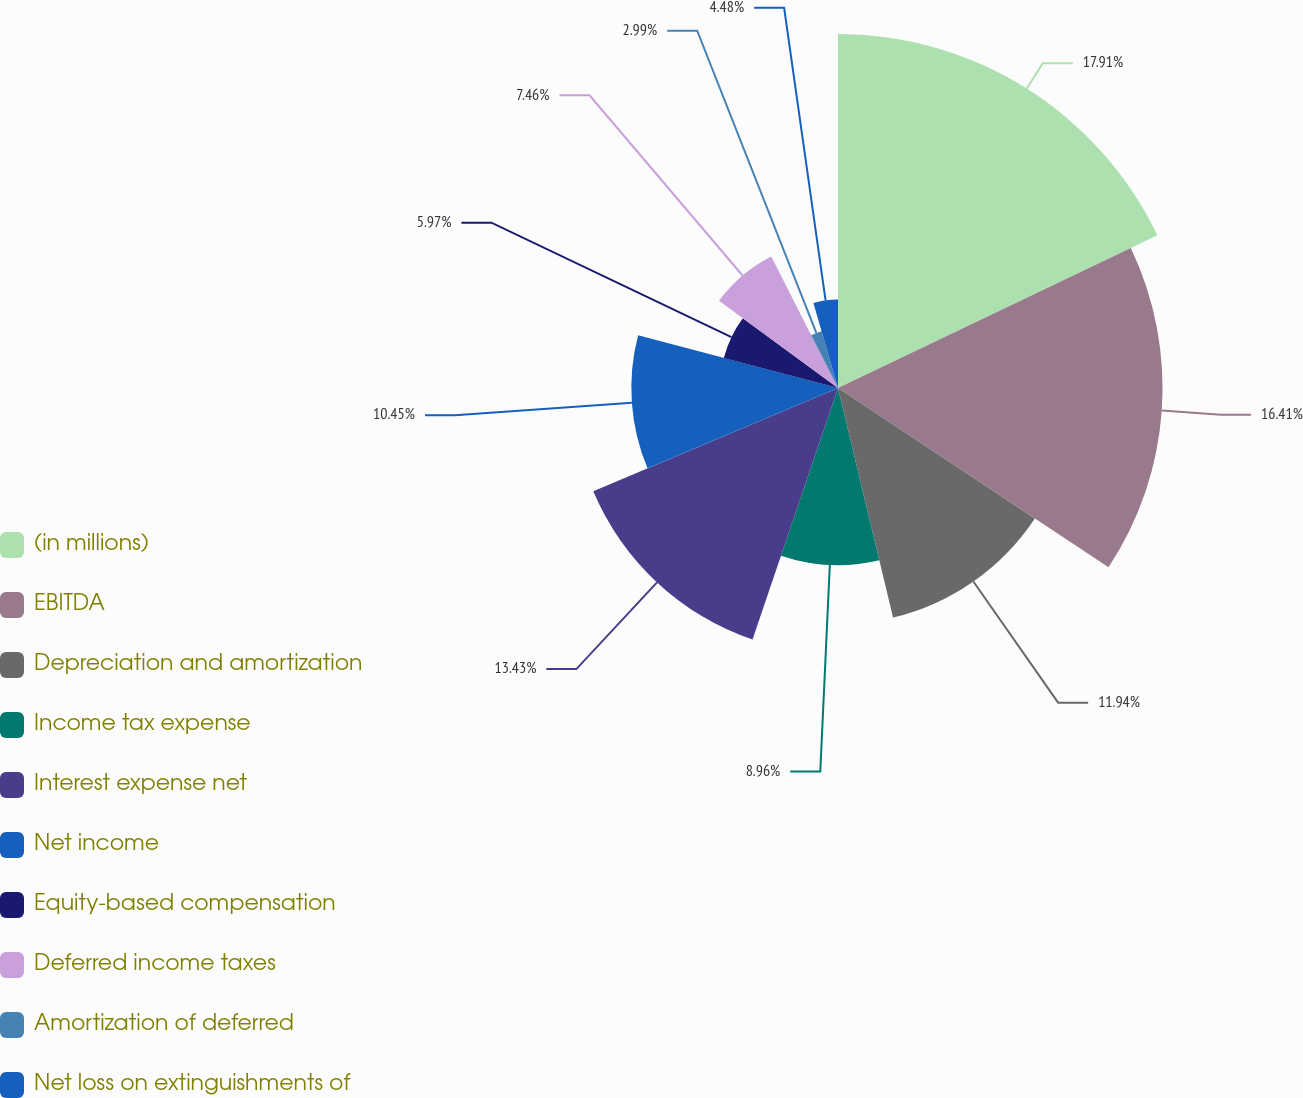Convert chart. <chart><loc_0><loc_0><loc_500><loc_500><pie_chart><fcel>(in millions)<fcel>EBITDA<fcel>Depreciation and amortization<fcel>Income tax expense<fcel>Interest expense net<fcel>Net income<fcel>Equity-based compensation<fcel>Deferred income taxes<fcel>Amortization of deferred<fcel>Net loss on extinguishments of<nl><fcel>17.9%<fcel>16.41%<fcel>11.94%<fcel>8.96%<fcel>13.43%<fcel>10.45%<fcel>5.97%<fcel>7.46%<fcel>2.99%<fcel>4.48%<nl></chart> 